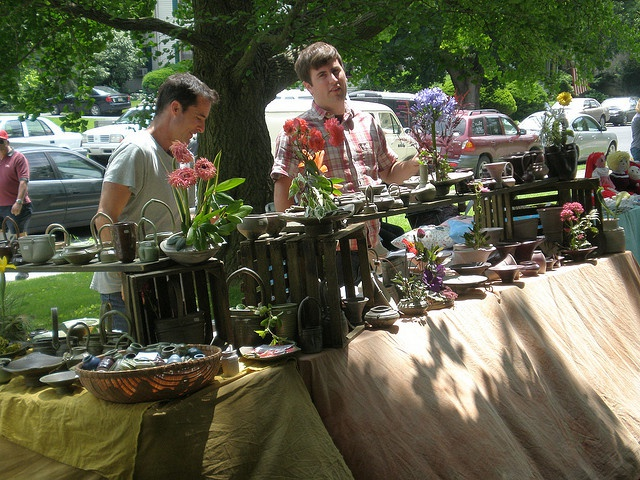Describe the objects in this image and their specific colors. I can see dining table in black, gray, darkgreen, and white tones, people in black, gray, maroon, and white tones, people in black, gray, white, and maroon tones, dining table in black, gray, darkgreen, and darkgray tones, and chair in black, darkgreen, and gray tones in this image. 